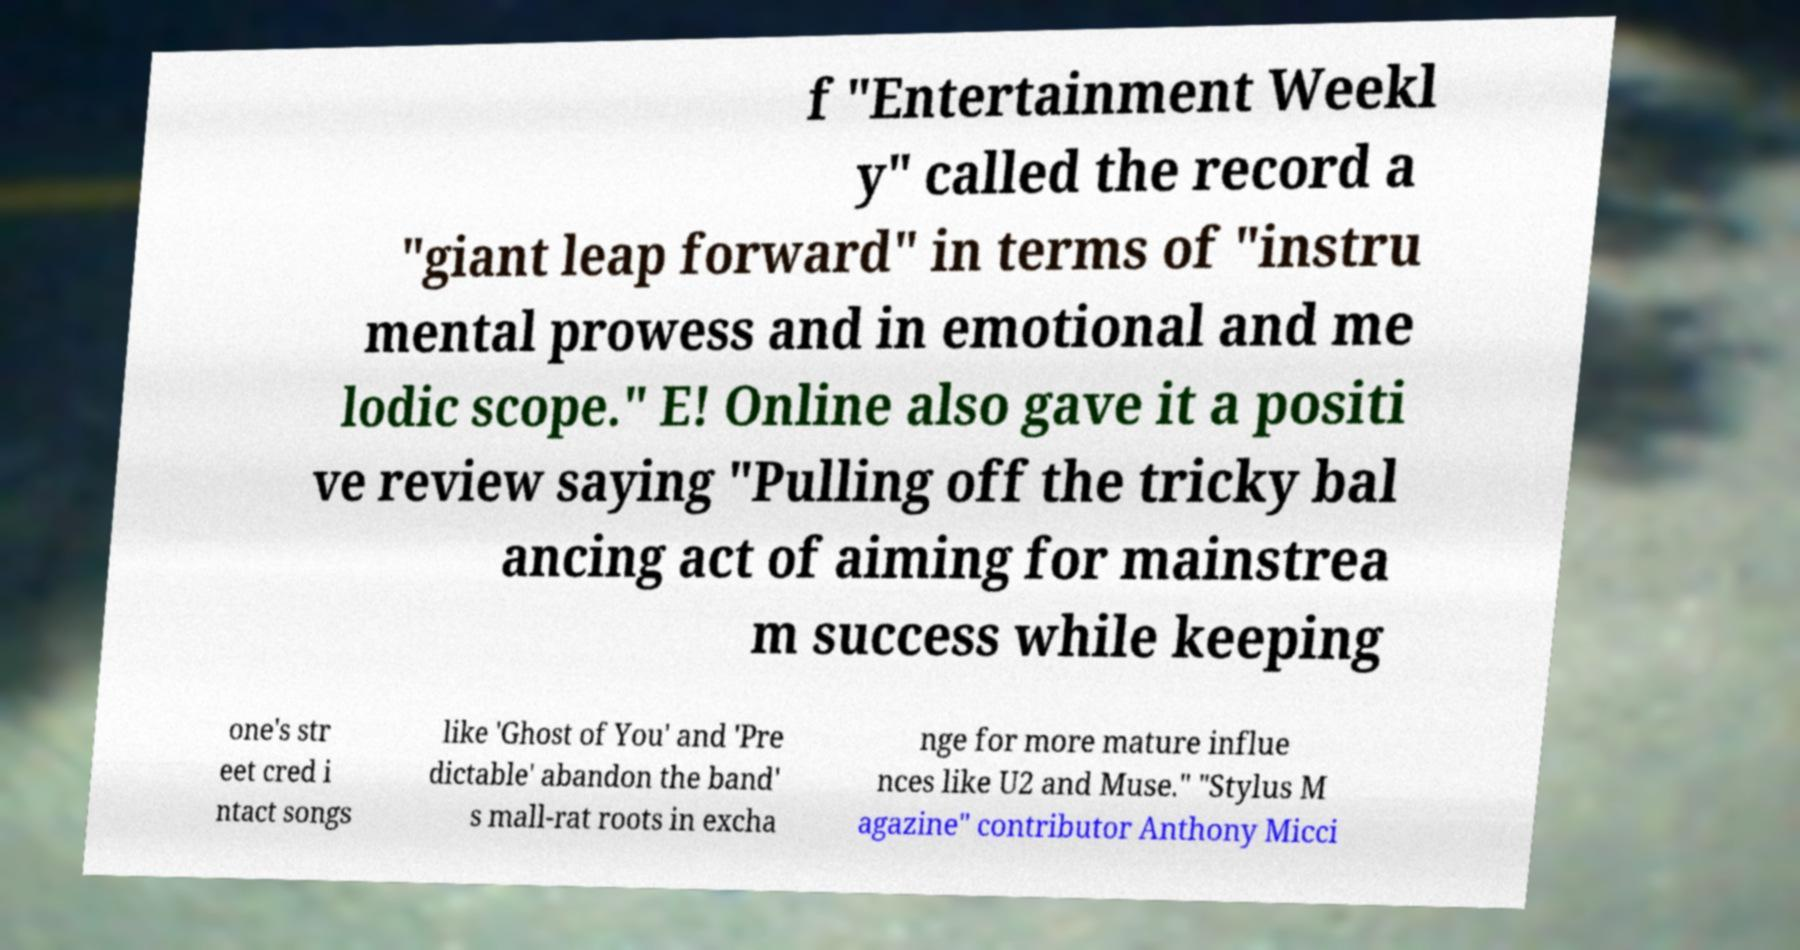What messages or text are displayed in this image? I need them in a readable, typed format. f "Entertainment Weekl y" called the record a "giant leap forward" in terms of "instru mental prowess and in emotional and me lodic scope." E! Online also gave it a positi ve review saying "Pulling off the tricky bal ancing act of aiming for mainstrea m success while keeping one's str eet cred i ntact songs like 'Ghost of You' and 'Pre dictable' abandon the band' s mall-rat roots in excha nge for more mature influe nces like U2 and Muse." "Stylus M agazine" contributor Anthony Micci 